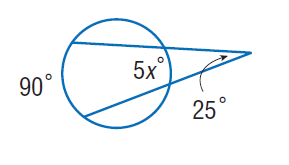Answer the mathemtical geometry problem and directly provide the correct option letter.
Question: Find x. Assume that any segment that appears to be tangent is tangent.
Choices: A: 8 B: 25 C: 40 D: 90 A 